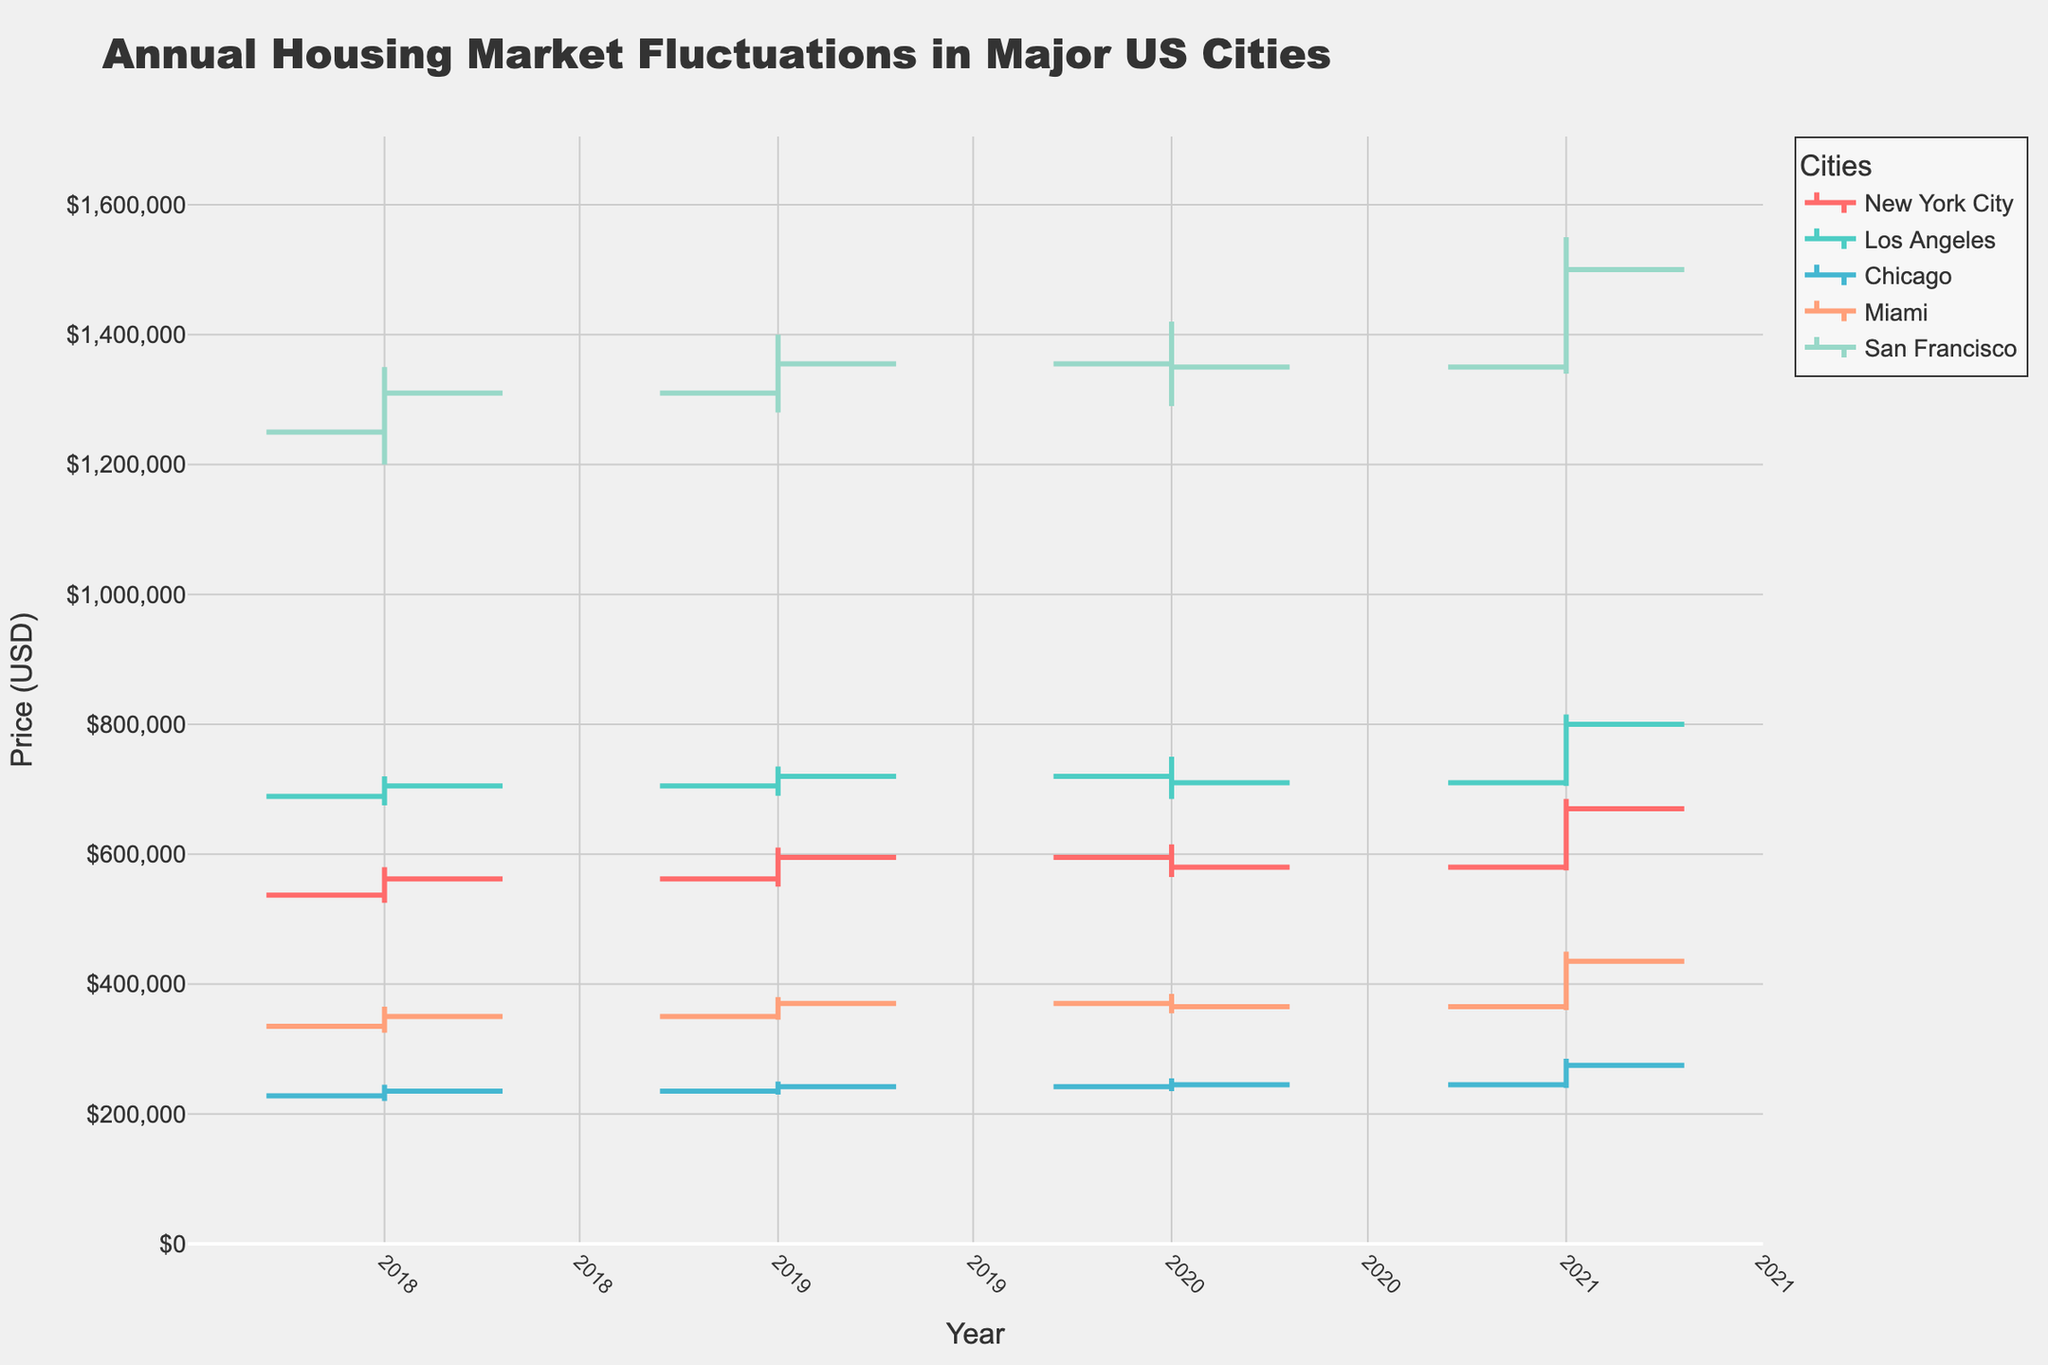What's the title of the figure? The title is at the top of the figure.
Answer: Annual Housing Market Fluctuations in Major US Cities What colors are used for the different cities in the chart? The colors can be observed by looking at the lines corresponding to the cities in the figure's legend.
Answer: Red, teal, light blue, salmon, mint green In which city and year did the housing market see the highest price in the given period? Check the highest 'High' value across all cities and years. San Francisco in 2021 has a high of $1,550,000, which is the highest in the period.
Answer: San Francisco in 2021 Between 2018 and 2021, how much did the closing price of houses in Miami change? Subtract the closing price in 2018 from the closing price in 2021 for Miami. The closing price in 2021 is $435,000, and in 2018 it was $350,000. $435,000 - $350,000 = $85,000.
Answer: $85,000 Which city had a decrease in its closing price in 2020 compared to 2019? Compare the closing prices of 2019 and 2020 for all cities. New York City had a closing price of $595,000 in 2019 and $580,000 in 2020.
Answer: New York City Among the major cities, which experienced the smallest closing price change from 2018 to 2021? Calculate the difference in the closing prices between 2018 and 2021 for each city and compare them. Chicago’s closing prices changed from $235,000 in 2018 to $275,000 in 2021, which is a difference of $40,000, the smallest among all cities.
Answer: Chicago By comparing the line colors, which city's housing market showed the highest volatility in 2021? Housing market volatility can be inferred from the range between the highest 'High' and the lowest 'Low' values in 2021. San Francisco showed a range from $1,340,000 to $1,550,000, indicating the highest volatility.
Answer: San Francisco How many cities are represented in the figure? Count the number of unique cities listed in the figure legend.
Answer: Five Which city had the highest increase in its closing price from 2020 to 2021? Calculate the difference in closing prices from 2020 to 2021 for each city and compare them. San Francisco's closing price increased from $1,350,000 in 2020 to $1,500,000 in 2021, which is an increase of $150,000, the highest among the cities.
Answer: San Francisco Of the five cities, which saw the most consistent upward trend in housing prices from 2018 to 2021? An upward trend can be determined by checking the closing prices across the years for each city. Los Angeles shows a consistent increase in its closing prices each year, from $705,000 in 2018 to $800,000 in 2021.
Answer: Los Angeles 